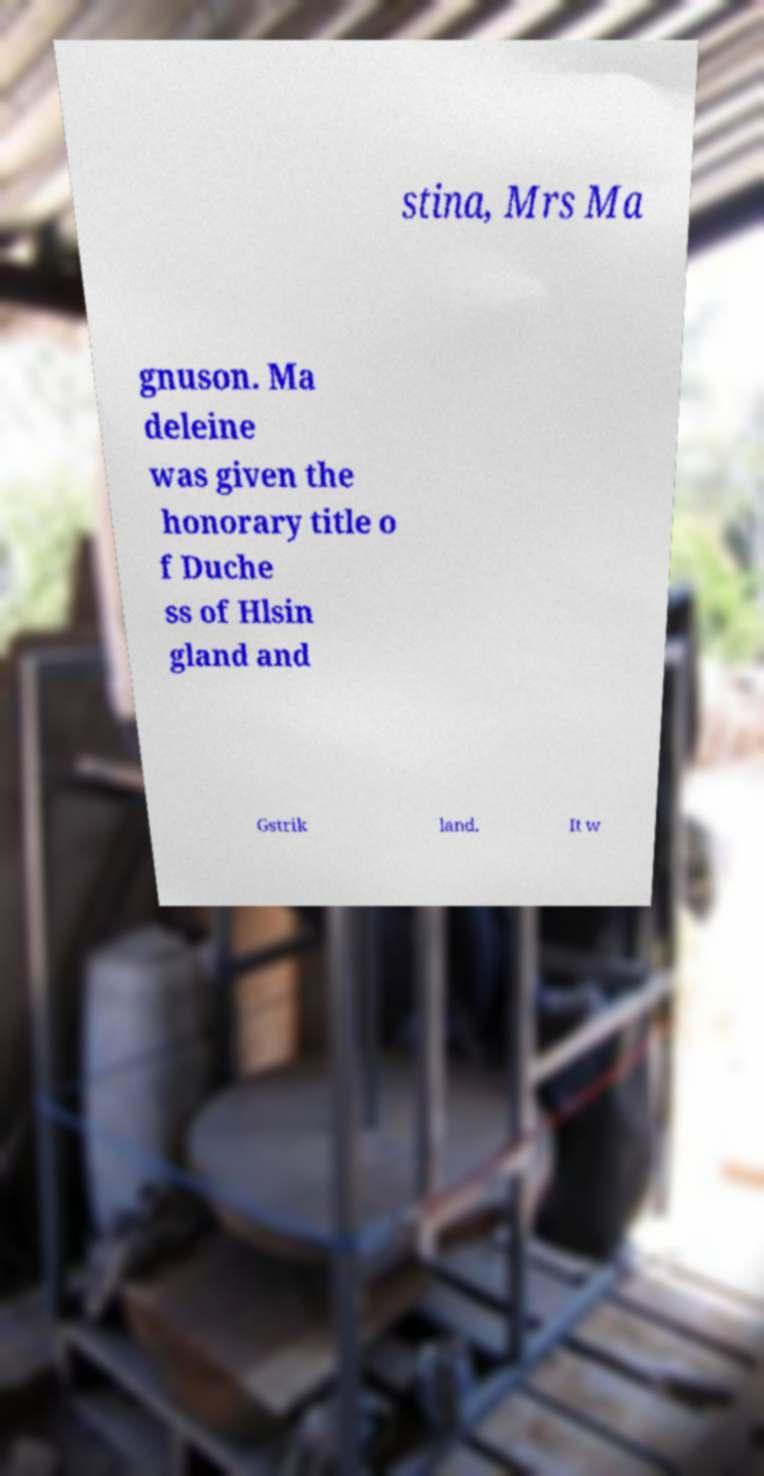Please identify and transcribe the text found in this image. stina, Mrs Ma gnuson. Ma deleine was given the honorary title o f Duche ss of Hlsin gland and Gstrik land. It w 